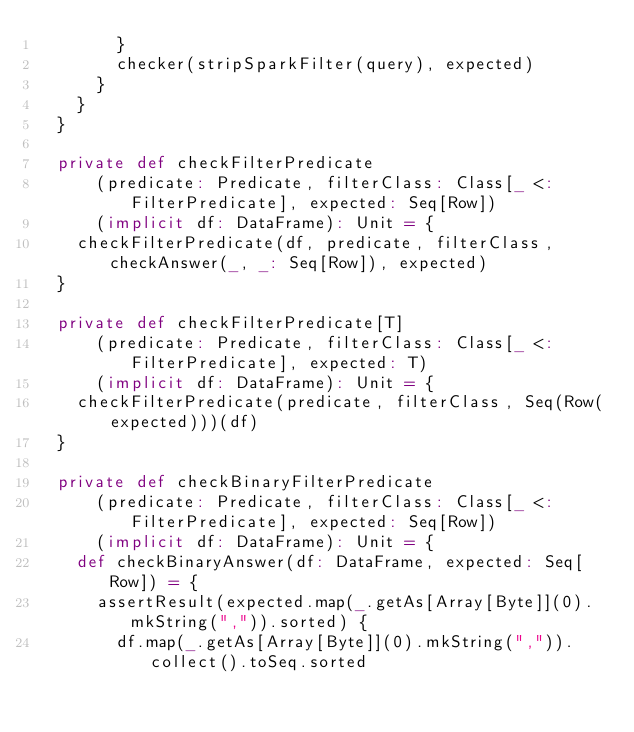Convert code to text. <code><loc_0><loc_0><loc_500><loc_500><_Scala_>        }
        checker(stripSparkFilter(query), expected)
      }
    }
  }

  private def checkFilterPredicate
      (predicate: Predicate, filterClass: Class[_ <: FilterPredicate], expected: Seq[Row])
      (implicit df: DataFrame): Unit = {
    checkFilterPredicate(df, predicate, filterClass, checkAnswer(_, _: Seq[Row]), expected)
  }

  private def checkFilterPredicate[T]
      (predicate: Predicate, filterClass: Class[_ <: FilterPredicate], expected: T)
      (implicit df: DataFrame): Unit = {
    checkFilterPredicate(predicate, filterClass, Seq(Row(expected)))(df)
  }

  private def checkBinaryFilterPredicate
      (predicate: Predicate, filterClass: Class[_ <: FilterPredicate], expected: Seq[Row])
      (implicit df: DataFrame): Unit = {
    def checkBinaryAnswer(df: DataFrame, expected: Seq[Row]) = {
      assertResult(expected.map(_.getAs[Array[Byte]](0).mkString(",")).sorted) {
        df.map(_.getAs[Array[Byte]](0).mkString(",")).collect().toSeq.sorted</code> 